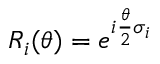<formula> <loc_0><loc_0><loc_500><loc_500>R _ { i } ( \theta ) = e ^ { i \frac { \theta } { 2 } \sigma _ { i } }</formula> 